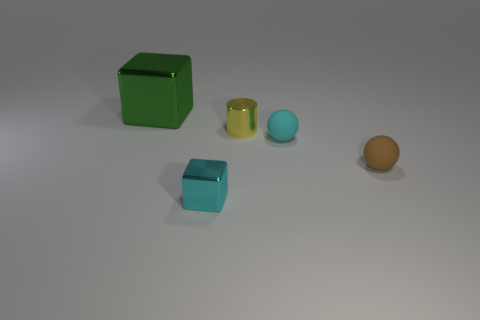Add 1 purple metallic cylinders. How many objects exist? 6 Subtract all cylinders. How many objects are left? 4 Subtract all cyan things. Subtract all small metal cubes. How many objects are left? 2 Add 2 metal cylinders. How many metal cylinders are left? 3 Add 1 large green metallic objects. How many large green metallic objects exist? 2 Subtract 1 cyan cubes. How many objects are left? 4 